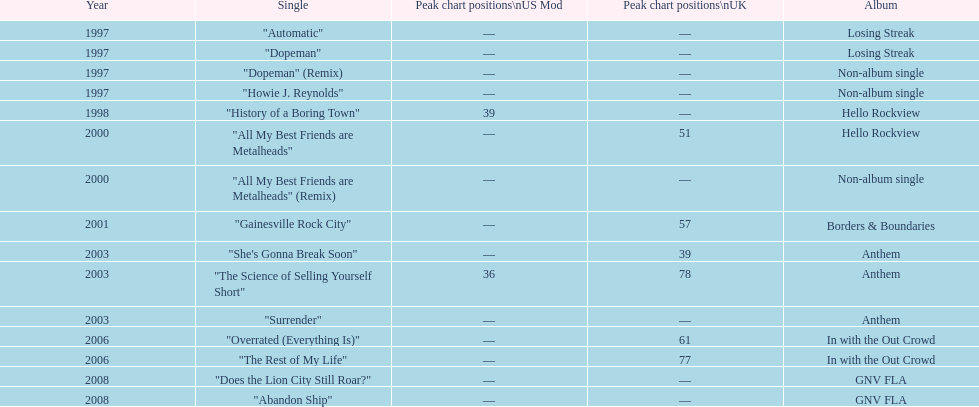Name one other single that was on the losing streak album besides "dopeman". "Automatic". 